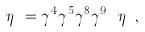<formula> <loc_0><loc_0><loc_500><loc_500>\eta _ { \, ^ { l } _ { r } } = \gamma ^ { 4 } \gamma ^ { 5 } \gamma ^ { 8 } \gamma ^ { 9 } \ \eta _ { \, ^ { l } _ { r } } \, ,</formula> 